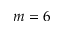<formula> <loc_0><loc_0><loc_500><loc_500>m = 6</formula> 